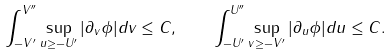<formula> <loc_0><loc_0><loc_500><loc_500>\int _ { - V ^ { \prime } } ^ { V ^ { \prime \prime } } \sup _ { u \geq - U ^ { \prime } } | \partial _ { v } \phi | d v \leq C , \quad \int _ { - U ^ { \prime } } ^ { U ^ { \prime \prime } } \sup _ { v \geq - V ^ { \prime } } | \partial _ { u } \phi | d u \leq C .</formula> 